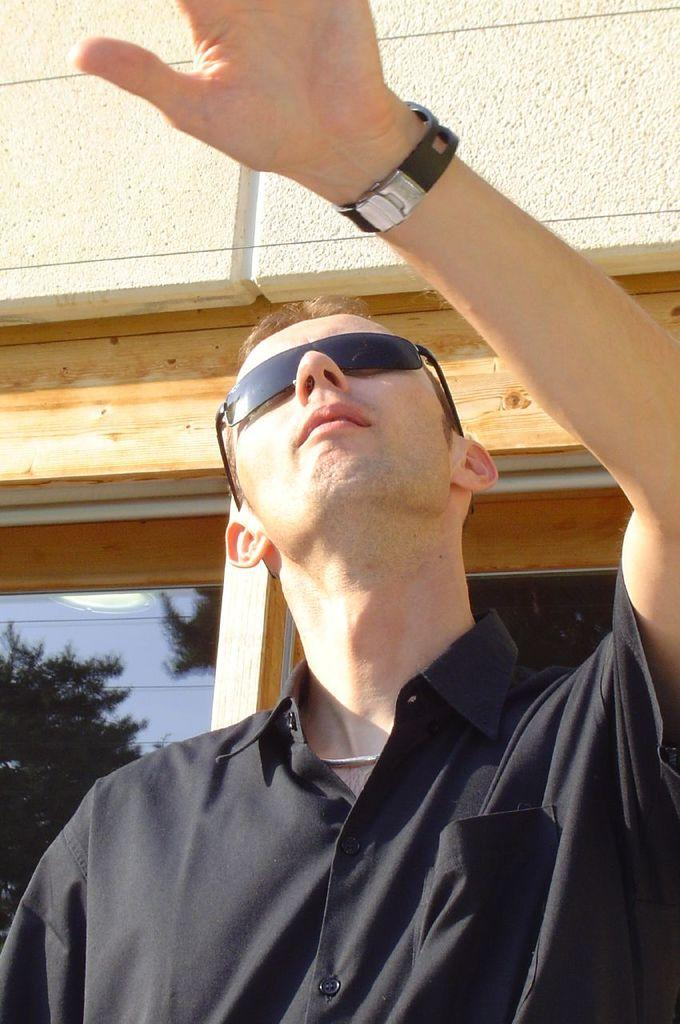What is the main subject in the foreground of the image? There is a person in the foreground of the image. What can be seen in the background of the image? There is a wall, a door, and a pipe in the background of the image. What book is the person reading on the desk in the image? There is no book or desk present in the image. What part of the person's body is visible in the image? The provided facts do not specify any part of the person's body that is visible in the image. 